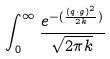<formula> <loc_0><loc_0><loc_500><loc_500>\int _ { 0 } ^ { \infty } \frac { e ^ { - ( \frac { ( q \cdot g ) ^ { 2 } } { 2 k } ) } } { \sqrt { 2 \pi k } }</formula> 